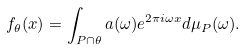Convert formula to latex. <formula><loc_0><loc_0><loc_500><loc_500>f _ { \theta } ( x ) = \int _ { P \cap \theta } a ( \omega ) e ^ { 2 \pi i \omega x } d \mu _ { P } ( \omega ) .</formula> 